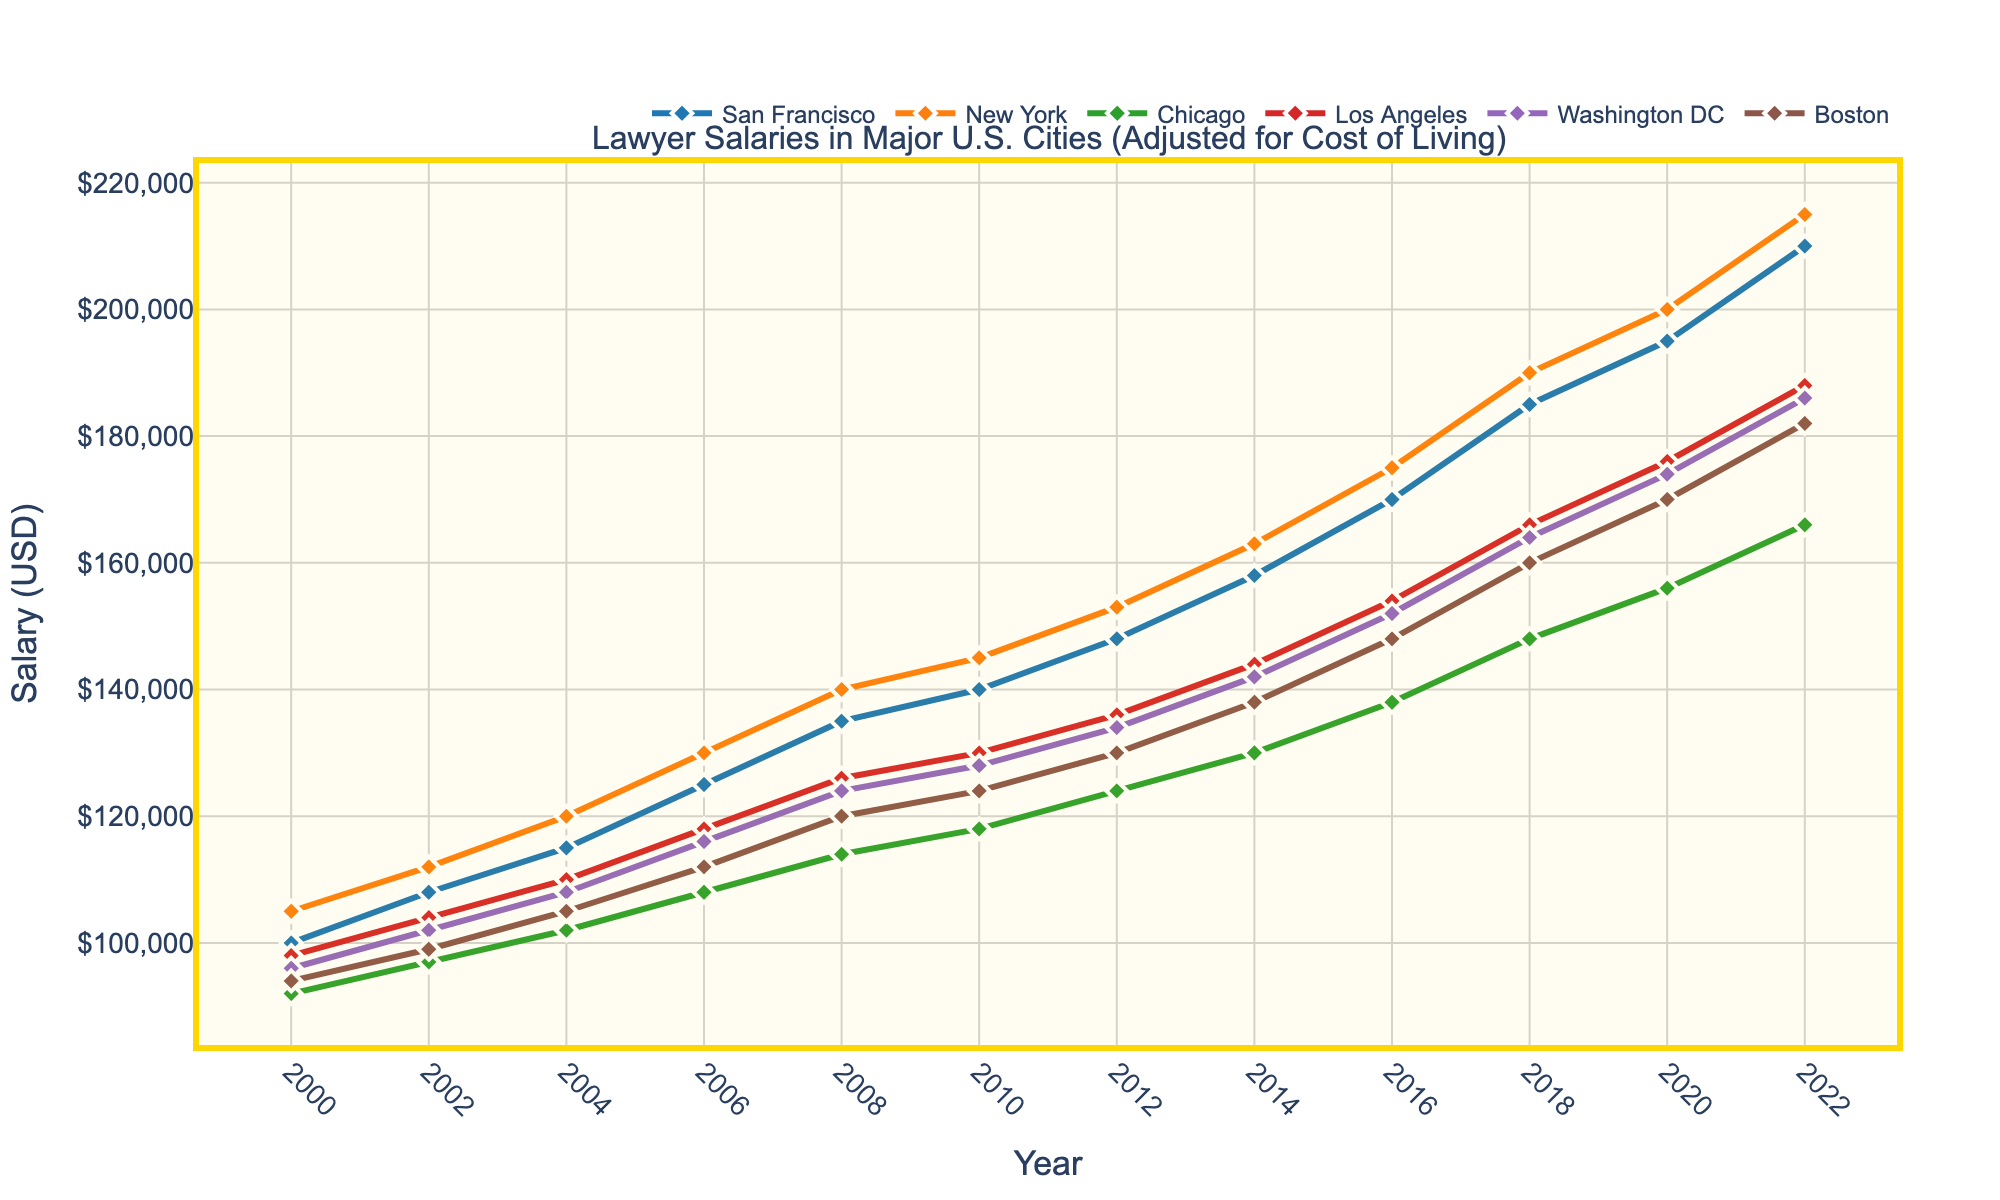What is the highest lawyer salary in San Francisco by 2022? By visually inspecting the line chart, the data point for San Francisco in 2022 shows the highest salary. The line reaches up to the $210,000 mark.
Answer: $210,000 Which city experienced the largest increase in lawyer salary from 2000 to 2022? San Francisco's salary increased from $100,000 in 2000 to $210,000 in 2022, an increase of $110,000. Compare this with other cities to find the largest increase.
Answer: San Francisco By how much did the salary in New York increase from 2000 to 2010? In 2000, the lawyer salary in New York was $105,000. By 2010, it increased to $145,000. The difference is $145,000 - $105,000 = $40,000.
Answer: $40,000 In which year did Los Angeles surpass Chicago in lawyer salaries? From visual inspection, Los Angeles surpassed Chicago between 2006 and 2008. Check the exact salary difference and identify the year. In 2008, LA's ($126,000) salary was higher than Chicago's ($114,000).
Answer: 2008 What is the average lawyer salary in Boston over the years 2000 to 2022? Sum the salaries for Boston from 2000 to 2022 and divide by the number of data points: (94000 + 99000 + 105000 + 112000 + 120000 + 124000 + 130000 + 138000 + 148000 + 160000 + 170000 + 182000) / 12 = $129,583.33
Answer: $129,583.33 How many years did it take for the salary in Boston to double from the year 2000? Boston's lawyer salary in 2000 was $94,000. Double that amount is $188,000. By checking the chart, the salary reaches $182,000 by 2022, which is closest to double. Hence, it took from 2000 to 2022, which is 22 years.
Answer: 22 years Which city had higher lawyer salaries consistently from 2000 to 2022, San Francisco or New York? Visually compare the lines representing San Francisco and New York. New York's line remains consistently higher than San Francisco's throughout 2000 to 2022.
Answer: New York 